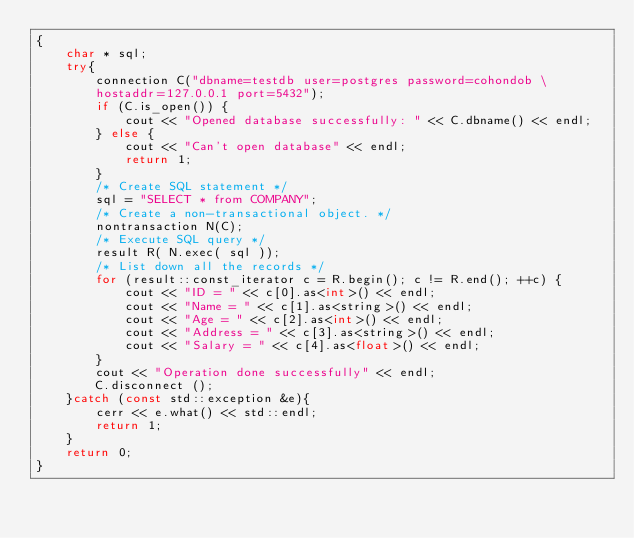<code> <loc_0><loc_0><loc_500><loc_500><_C++_>{
	char * sql;
	try{
		connection C("dbname=testdb user=postgres password=cohondob \
		hostaddr=127.0.0.1 port=5432");
		if (C.is_open()) {
			cout << "Opened database successfully: " << C.dbname() << endl;
		} else {
			cout << "Can't open database" << endl;
			return 1;
		}
		/* Create SQL statement */
		sql = "SELECT * from COMPANY";
		/* Create a non-transactional object. */
		nontransaction N(C);
		/* Execute SQL query */
		result R( N.exec( sql ));
		/* List down all the records */
		for (result::const_iterator c = R.begin(); c != R.end(); ++c) {
			cout << "ID = " << c[0].as<int>() << endl;
			cout << "Name = " << c[1].as<string>() << endl;
			cout << "Age = " << c[2].as<int>() << endl;
			cout << "Address = " << c[3].as<string>() << endl;
			cout << "Salary = " << c[4].as<float>() << endl;
		}
		cout << "Operation done successfully" << endl;
		C.disconnect ();
	}catch (const std::exception &e){
		cerr << e.what() << std::endl;
		return 1;
	}
	return 0;
}
</code> 